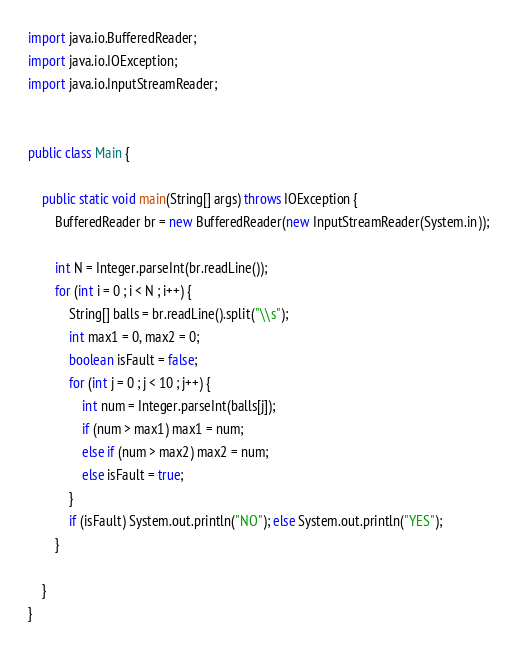Convert code to text. <code><loc_0><loc_0><loc_500><loc_500><_Java_>import java.io.BufferedReader;
import java.io.IOException;
import java.io.InputStreamReader;


public class Main {

	public static void main(String[] args) throws IOException {
		BufferedReader br = new BufferedReader(new InputStreamReader(System.in));

		int N = Integer.parseInt(br.readLine());
		for (int i = 0 ; i < N ; i++) {
			String[] balls = br.readLine().split("\\s");
			int max1 = 0, max2 = 0;
			boolean isFault = false;
			for (int j = 0 ; j < 10 ; j++) {
				int num = Integer.parseInt(balls[j]);
				if (num > max1) max1 = num;
				else if (num > max2) max2 = num;
				else isFault = true;
			}
			if (isFault) System.out.println("NO"); else System.out.println("YES");
		}

	}
}</code> 